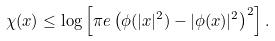<formula> <loc_0><loc_0><loc_500><loc_500>\chi ( x ) \leq \log \left [ \pi e \left ( \phi ( | x | ^ { 2 } ) - | \phi ( x ) | ^ { 2 } \right ) ^ { 2 } \right ] .</formula> 